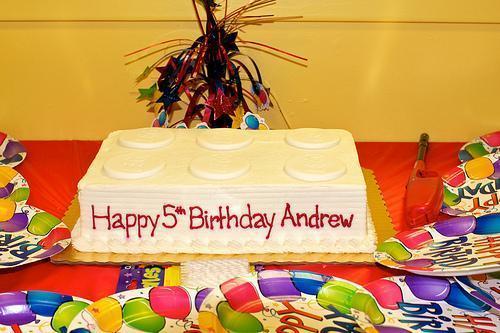How many lighters?
Give a very brief answer. 1. 